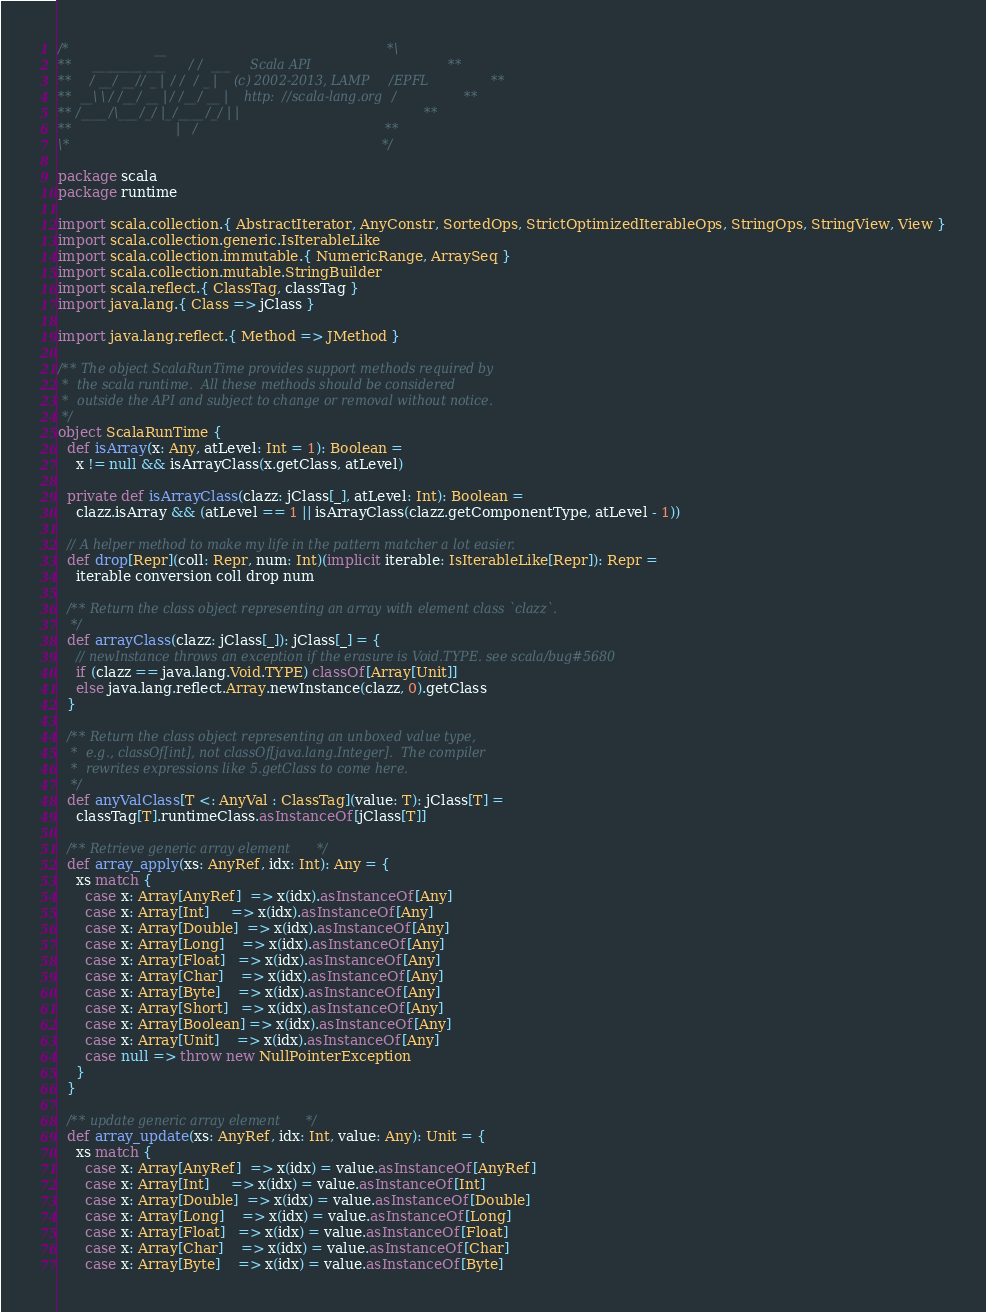Convert code to text. <code><loc_0><loc_0><loc_500><loc_500><_Scala_>/*                     __                                               *\
**     ________ ___   / /  ___     Scala API                            **
**    / __/ __// _ | / /  / _ |    (c) 2002-2013, LAMP/EPFL             **
**  __\ \/ /__/ __ |/ /__/ __ |    http://scala-lang.org/               **
** /____/\___/_/ |_/____/_/ | |                                         **
**                          |/                                          **
\*                                                                      */

package scala
package runtime

import scala.collection.{ AbstractIterator, AnyConstr, SortedOps, StrictOptimizedIterableOps, StringOps, StringView, View }
import scala.collection.generic.IsIterableLike
import scala.collection.immutable.{ NumericRange, ArraySeq }
import scala.collection.mutable.StringBuilder
import scala.reflect.{ ClassTag, classTag }
import java.lang.{ Class => jClass }

import java.lang.reflect.{ Method => JMethod }

/** The object ScalaRunTime provides support methods required by
 *  the scala runtime.  All these methods should be considered
 *  outside the API and subject to change or removal without notice.
 */
object ScalaRunTime {
  def isArray(x: Any, atLevel: Int = 1): Boolean =
    x != null && isArrayClass(x.getClass, atLevel)

  private def isArrayClass(clazz: jClass[_], atLevel: Int): Boolean =
    clazz.isArray && (atLevel == 1 || isArrayClass(clazz.getComponentType, atLevel - 1))

  // A helper method to make my life in the pattern matcher a lot easier.
  def drop[Repr](coll: Repr, num: Int)(implicit iterable: IsIterableLike[Repr]): Repr =
    iterable conversion coll drop num

  /** Return the class object representing an array with element class `clazz`.
   */
  def arrayClass(clazz: jClass[_]): jClass[_] = {
    // newInstance throws an exception if the erasure is Void.TYPE. see scala/bug#5680
    if (clazz == java.lang.Void.TYPE) classOf[Array[Unit]]
    else java.lang.reflect.Array.newInstance(clazz, 0).getClass
  }

  /** Return the class object representing an unboxed value type,
   *  e.g., classOf[int], not classOf[java.lang.Integer].  The compiler
   *  rewrites expressions like 5.getClass to come here.
   */
  def anyValClass[T <: AnyVal : ClassTag](value: T): jClass[T] =
    classTag[T].runtimeClass.asInstanceOf[jClass[T]]

  /** Retrieve generic array element */
  def array_apply(xs: AnyRef, idx: Int): Any = {
    xs match {
      case x: Array[AnyRef]  => x(idx).asInstanceOf[Any]
      case x: Array[Int]     => x(idx).asInstanceOf[Any]
      case x: Array[Double]  => x(idx).asInstanceOf[Any]
      case x: Array[Long]    => x(idx).asInstanceOf[Any]
      case x: Array[Float]   => x(idx).asInstanceOf[Any]
      case x: Array[Char]    => x(idx).asInstanceOf[Any]
      case x: Array[Byte]    => x(idx).asInstanceOf[Any]
      case x: Array[Short]   => x(idx).asInstanceOf[Any]
      case x: Array[Boolean] => x(idx).asInstanceOf[Any]
      case x: Array[Unit]    => x(idx).asInstanceOf[Any]
      case null => throw new NullPointerException
    }
  }

  /** update generic array element */
  def array_update(xs: AnyRef, idx: Int, value: Any): Unit = {
    xs match {
      case x: Array[AnyRef]  => x(idx) = value.asInstanceOf[AnyRef]
      case x: Array[Int]     => x(idx) = value.asInstanceOf[Int]
      case x: Array[Double]  => x(idx) = value.asInstanceOf[Double]
      case x: Array[Long]    => x(idx) = value.asInstanceOf[Long]
      case x: Array[Float]   => x(idx) = value.asInstanceOf[Float]
      case x: Array[Char]    => x(idx) = value.asInstanceOf[Char]
      case x: Array[Byte]    => x(idx) = value.asInstanceOf[Byte]</code> 